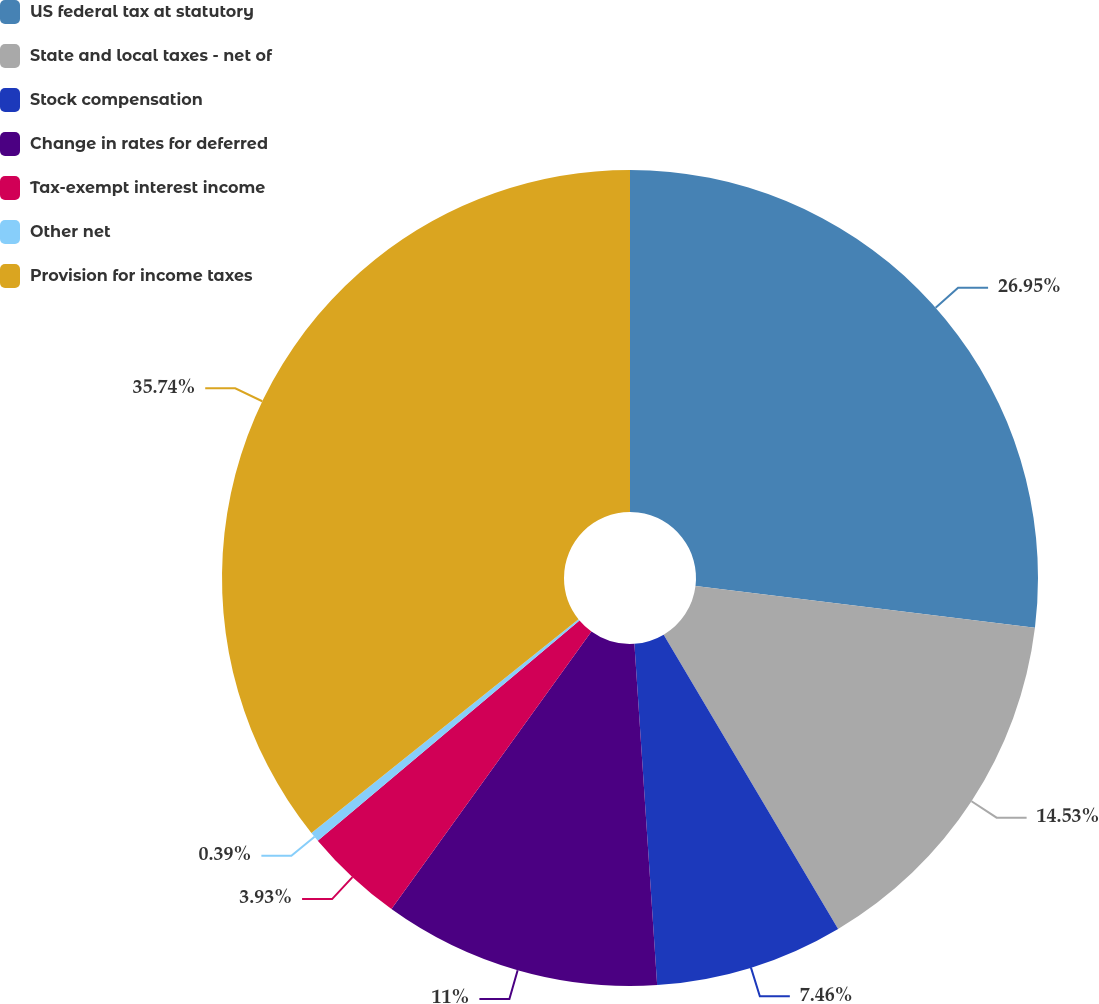Convert chart. <chart><loc_0><loc_0><loc_500><loc_500><pie_chart><fcel>US federal tax at statutory<fcel>State and local taxes - net of<fcel>Stock compensation<fcel>Change in rates for deferred<fcel>Tax-exempt interest income<fcel>Other net<fcel>Provision for income taxes<nl><fcel>26.95%<fcel>14.53%<fcel>7.46%<fcel>11.0%<fcel>3.93%<fcel>0.39%<fcel>35.74%<nl></chart> 